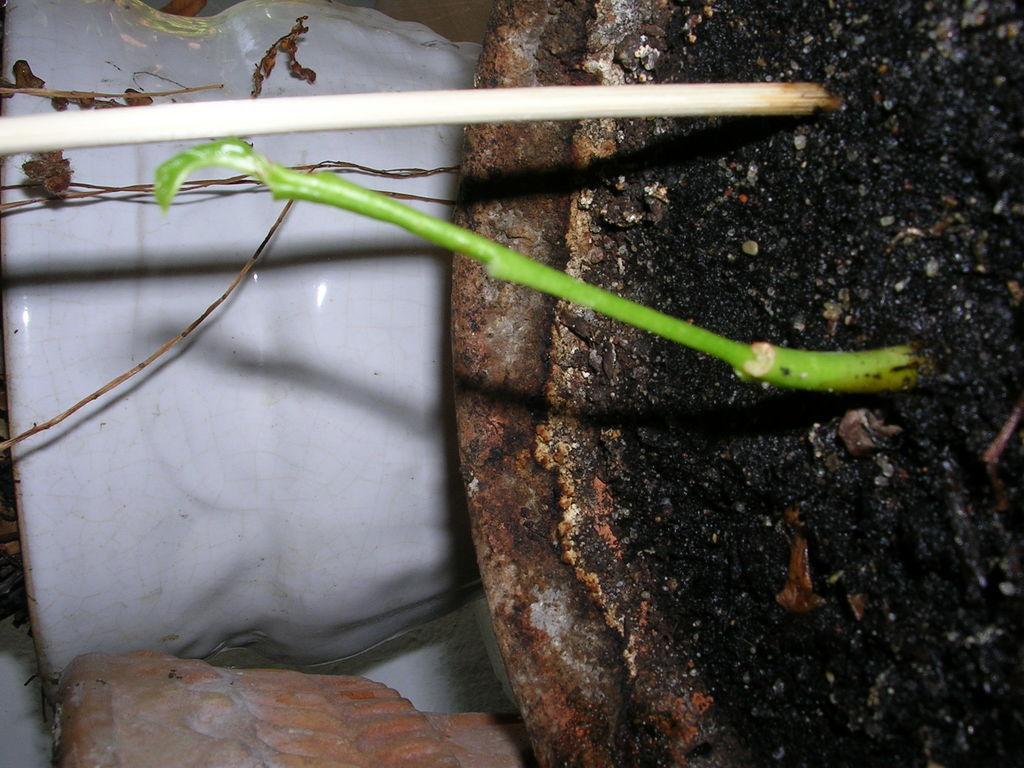Can you describe this image briefly? In this image we can see a flower pot on the right there is a stem and a stick. 